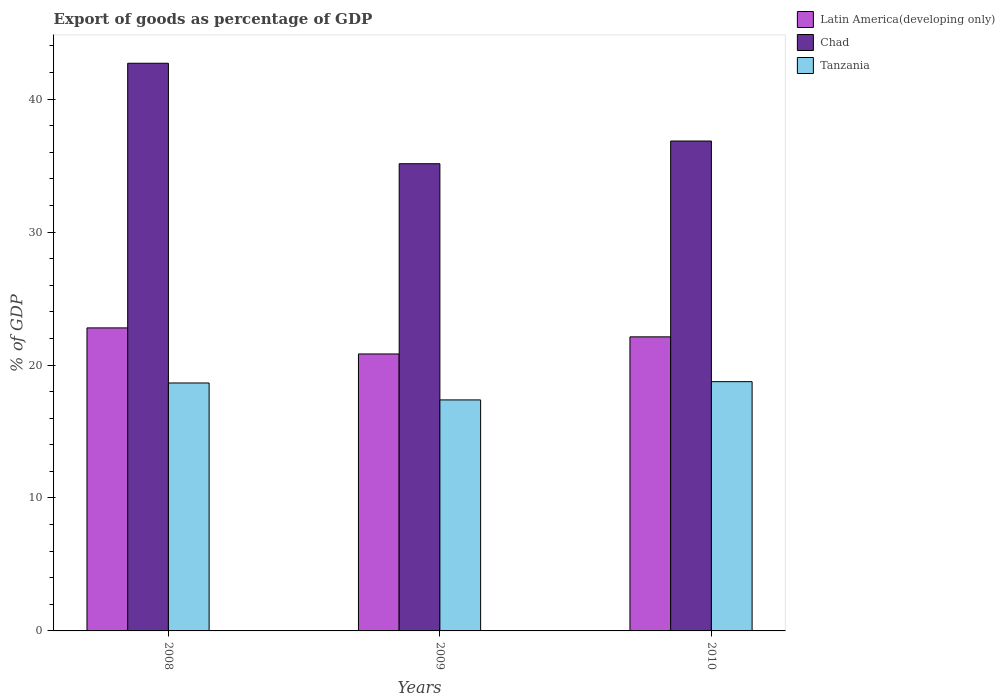How many different coloured bars are there?
Ensure brevity in your answer.  3. Are the number of bars on each tick of the X-axis equal?
Provide a short and direct response. Yes. How many bars are there on the 3rd tick from the left?
Offer a terse response. 3. In how many cases, is the number of bars for a given year not equal to the number of legend labels?
Your answer should be compact. 0. What is the export of goods as percentage of GDP in Latin America(developing only) in 2008?
Your response must be concise. 22.79. Across all years, what is the maximum export of goods as percentage of GDP in Tanzania?
Your answer should be compact. 18.75. Across all years, what is the minimum export of goods as percentage of GDP in Tanzania?
Your answer should be compact. 17.37. In which year was the export of goods as percentage of GDP in Chad minimum?
Keep it short and to the point. 2009. What is the total export of goods as percentage of GDP in Chad in the graph?
Provide a short and direct response. 114.68. What is the difference between the export of goods as percentage of GDP in Tanzania in 2008 and that in 2010?
Your response must be concise. -0.1. What is the difference between the export of goods as percentage of GDP in Tanzania in 2010 and the export of goods as percentage of GDP in Chad in 2009?
Make the answer very short. -16.39. What is the average export of goods as percentage of GDP in Latin America(developing only) per year?
Your answer should be compact. 21.91. In the year 2008, what is the difference between the export of goods as percentage of GDP in Chad and export of goods as percentage of GDP in Latin America(developing only)?
Offer a very short reply. 19.9. What is the ratio of the export of goods as percentage of GDP in Latin America(developing only) in 2009 to that in 2010?
Your response must be concise. 0.94. Is the export of goods as percentage of GDP in Tanzania in 2008 less than that in 2009?
Your response must be concise. No. Is the difference between the export of goods as percentage of GDP in Chad in 2009 and 2010 greater than the difference between the export of goods as percentage of GDP in Latin America(developing only) in 2009 and 2010?
Make the answer very short. No. What is the difference between the highest and the second highest export of goods as percentage of GDP in Tanzania?
Offer a terse response. 0.1. What is the difference between the highest and the lowest export of goods as percentage of GDP in Tanzania?
Your response must be concise. 1.37. In how many years, is the export of goods as percentage of GDP in Latin America(developing only) greater than the average export of goods as percentage of GDP in Latin America(developing only) taken over all years?
Your answer should be very brief. 2. Is the sum of the export of goods as percentage of GDP in Latin America(developing only) in 2009 and 2010 greater than the maximum export of goods as percentage of GDP in Tanzania across all years?
Give a very brief answer. Yes. What does the 3rd bar from the left in 2008 represents?
Offer a terse response. Tanzania. What does the 1st bar from the right in 2010 represents?
Your answer should be very brief. Tanzania. Is it the case that in every year, the sum of the export of goods as percentage of GDP in Tanzania and export of goods as percentage of GDP in Latin America(developing only) is greater than the export of goods as percentage of GDP in Chad?
Provide a short and direct response. No. What is the difference between two consecutive major ticks on the Y-axis?
Provide a succinct answer. 10. Where does the legend appear in the graph?
Your answer should be compact. Top right. What is the title of the graph?
Give a very brief answer. Export of goods as percentage of GDP. Does "Egypt, Arab Rep." appear as one of the legend labels in the graph?
Offer a very short reply. No. What is the label or title of the X-axis?
Your answer should be compact. Years. What is the label or title of the Y-axis?
Provide a short and direct response. % of GDP. What is the % of GDP of Latin America(developing only) in 2008?
Provide a succinct answer. 22.79. What is the % of GDP of Chad in 2008?
Give a very brief answer. 42.69. What is the % of GDP of Tanzania in 2008?
Provide a succinct answer. 18.65. What is the % of GDP in Latin America(developing only) in 2009?
Offer a very short reply. 20.83. What is the % of GDP of Chad in 2009?
Provide a short and direct response. 35.14. What is the % of GDP of Tanzania in 2009?
Make the answer very short. 17.37. What is the % of GDP in Latin America(developing only) in 2010?
Your answer should be compact. 22.12. What is the % of GDP of Chad in 2010?
Offer a terse response. 36.85. What is the % of GDP in Tanzania in 2010?
Make the answer very short. 18.75. Across all years, what is the maximum % of GDP in Latin America(developing only)?
Give a very brief answer. 22.79. Across all years, what is the maximum % of GDP in Chad?
Your answer should be compact. 42.69. Across all years, what is the maximum % of GDP in Tanzania?
Make the answer very short. 18.75. Across all years, what is the minimum % of GDP in Latin America(developing only)?
Your answer should be compact. 20.83. Across all years, what is the minimum % of GDP in Chad?
Provide a succinct answer. 35.14. Across all years, what is the minimum % of GDP in Tanzania?
Provide a short and direct response. 17.37. What is the total % of GDP of Latin America(developing only) in the graph?
Offer a terse response. 65.74. What is the total % of GDP in Chad in the graph?
Offer a terse response. 114.68. What is the total % of GDP of Tanzania in the graph?
Provide a short and direct response. 54.77. What is the difference between the % of GDP in Latin America(developing only) in 2008 and that in 2009?
Provide a succinct answer. 1.96. What is the difference between the % of GDP in Chad in 2008 and that in 2009?
Ensure brevity in your answer.  7.56. What is the difference between the % of GDP in Tanzania in 2008 and that in 2009?
Provide a succinct answer. 1.27. What is the difference between the % of GDP of Latin America(developing only) in 2008 and that in 2010?
Your answer should be compact. 0.67. What is the difference between the % of GDP of Chad in 2008 and that in 2010?
Your answer should be compact. 5.85. What is the difference between the % of GDP in Tanzania in 2008 and that in 2010?
Provide a succinct answer. -0.1. What is the difference between the % of GDP of Latin America(developing only) in 2009 and that in 2010?
Give a very brief answer. -1.29. What is the difference between the % of GDP of Chad in 2009 and that in 2010?
Your answer should be very brief. -1.71. What is the difference between the % of GDP in Tanzania in 2009 and that in 2010?
Give a very brief answer. -1.37. What is the difference between the % of GDP of Latin America(developing only) in 2008 and the % of GDP of Chad in 2009?
Ensure brevity in your answer.  -12.35. What is the difference between the % of GDP in Latin America(developing only) in 2008 and the % of GDP in Tanzania in 2009?
Offer a terse response. 5.42. What is the difference between the % of GDP in Chad in 2008 and the % of GDP in Tanzania in 2009?
Provide a succinct answer. 25.32. What is the difference between the % of GDP in Latin America(developing only) in 2008 and the % of GDP in Chad in 2010?
Give a very brief answer. -14.05. What is the difference between the % of GDP in Latin America(developing only) in 2008 and the % of GDP in Tanzania in 2010?
Give a very brief answer. 4.04. What is the difference between the % of GDP in Chad in 2008 and the % of GDP in Tanzania in 2010?
Your answer should be compact. 23.95. What is the difference between the % of GDP of Latin America(developing only) in 2009 and the % of GDP of Chad in 2010?
Offer a terse response. -16.02. What is the difference between the % of GDP of Latin America(developing only) in 2009 and the % of GDP of Tanzania in 2010?
Your response must be concise. 2.08. What is the difference between the % of GDP of Chad in 2009 and the % of GDP of Tanzania in 2010?
Your answer should be very brief. 16.39. What is the average % of GDP of Latin America(developing only) per year?
Give a very brief answer. 21.91. What is the average % of GDP of Chad per year?
Your answer should be compact. 38.23. What is the average % of GDP in Tanzania per year?
Ensure brevity in your answer.  18.26. In the year 2008, what is the difference between the % of GDP of Latin America(developing only) and % of GDP of Chad?
Your answer should be compact. -19.9. In the year 2008, what is the difference between the % of GDP of Latin America(developing only) and % of GDP of Tanzania?
Give a very brief answer. 4.14. In the year 2008, what is the difference between the % of GDP in Chad and % of GDP in Tanzania?
Offer a very short reply. 24.05. In the year 2009, what is the difference between the % of GDP in Latin America(developing only) and % of GDP in Chad?
Keep it short and to the point. -14.31. In the year 2009, what is the difference between the % of GDP in Latin America(developing only) and % of GDP in Tanzania?
Offer a terse response. 3.46. In the year 2009, what is the difference between the % of GDP in Chad and % of GDP in Tanzania?
Your response must be concise. 17.76. In the year 2010, what is the difference between the % of GDP of Latin America(developing only) and % of GDP of Chad?
Keep it short and to the point. -14.73. In the year 2010, what is the difference between the % of GDP of Latin America(developing only) and % of GDP of Tanzania?
Keep it short and to the point. 3.37. In the year 2010, what is the difference between the % of GDP of Chad and % of GDP of Tanzania?
Provide a succinct answer. 18.1. What is the ratio of the % of GDP in Latin America(developing only) in 2008 to that in 2009?
Provide a succinct answer. 1.09. What is the ratio of the % of GDP in Chad in 2008 to that in 2009?
Your answer should be very brief. 1.22. What is the ratio of the % of GDP of Tanzania in 2008 to that in 2009?
Keep it short and to the point. 1.07. What is the ratio of the % of GDP in Latin America(developing only) in 2008 to that in 2010?
Offer a terse response. 1.03. What is the ratio of the % of GDP of Chad in 2008 to that in 2010?
Offer a very short reply. 1.16. What is the ratio of the % of GDP in Tanzania in 2008 to that in 2010?
Your answer should be very brief. 0.99. What is the ratio of the % of GDP in Latin America(developing only) in 2009 to that in 2010?
Your answer should be very brief. 0.94. What is the ratio of the % of GDP of Chad in 2009 to that in 2010?
Provide a short and direct response. 0.95. What is the ratio of the % of GDP of Tanzania in 2009 to that in 2010?
Your answer should be compact. 0.93. What is the difference between the highest and the second highest % of GDP in Latin America(developing only)?
Provide a succinct answer. 0.67. What is the difference between the highest and the second highest % of GDP in Chad?
Keep it short and to the point. 5.85. What is the difference between the highest and the second highest % of GDP in Tanzania?
Offer a terse response. 0.1. What is the difference between the highest and the lowest % of GDP in Latin America(developing only)?
Your answer should be compact. 1.96. What is the difference between the highest and the lowest % of GDP in Chad?
Give a very brief answer. 7.56. What is the difference between the highest and the lowest % of GDP of Tanzania?
Provide a succinct answer. 1.37. 